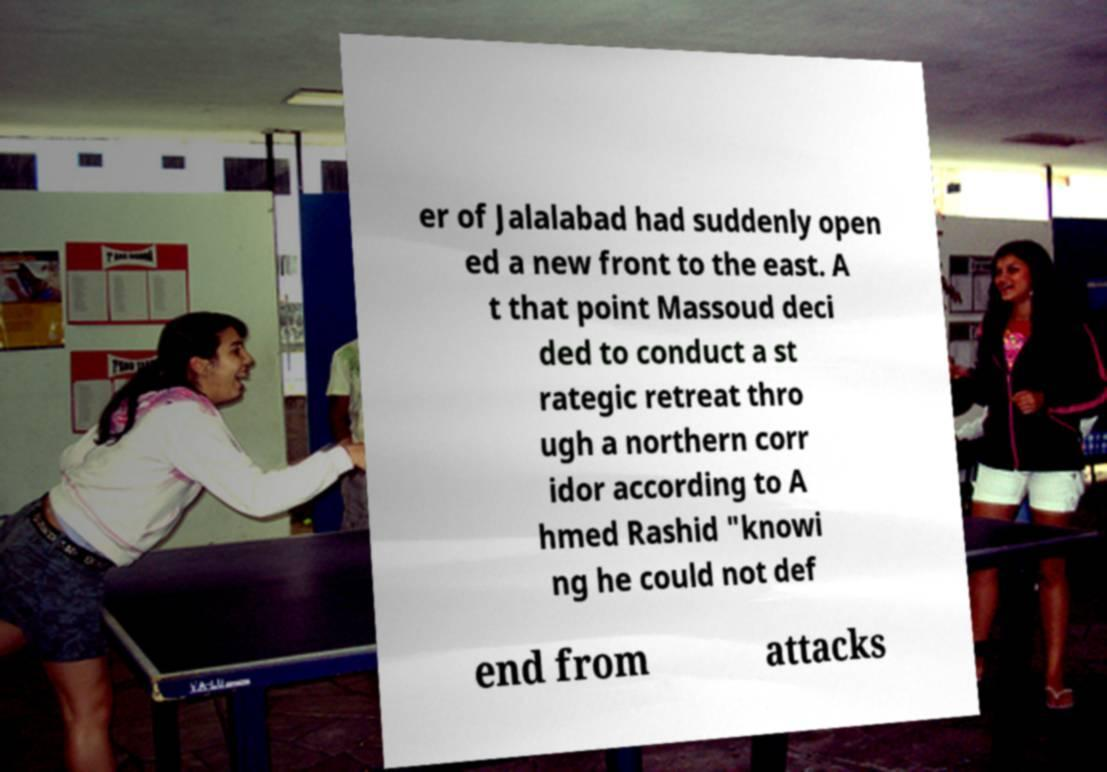What messages or text are displayed in this image? I need them in a readable, typed format. er of Jalalabad had suddenly open ed a new front to the east. A t that point Massoud deci ded to conduct a st rategic retreat thro ugh a northern corr idor according to A hmed Rashid "knowi ng he could not def end from attacks 